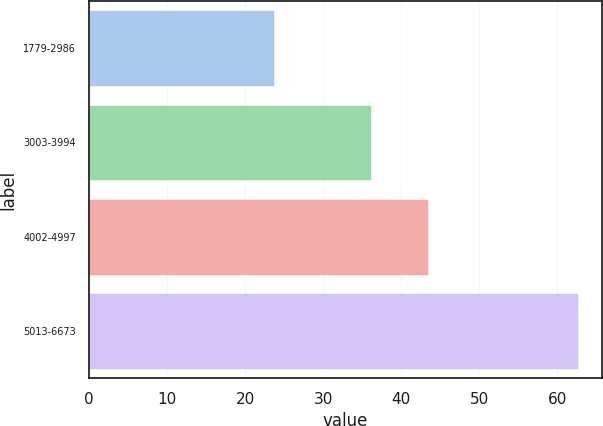<chart> <loc_0><loc_0><loc_500><loc_500><bar_chart><fcel>1779-2986<fcel>3003-3994<fcel>4002-4997<fcel>5013-6673<nl><fcel>23.66<fcel>36.17<fcel>43.48<fcel>62.62<nl></chart> 